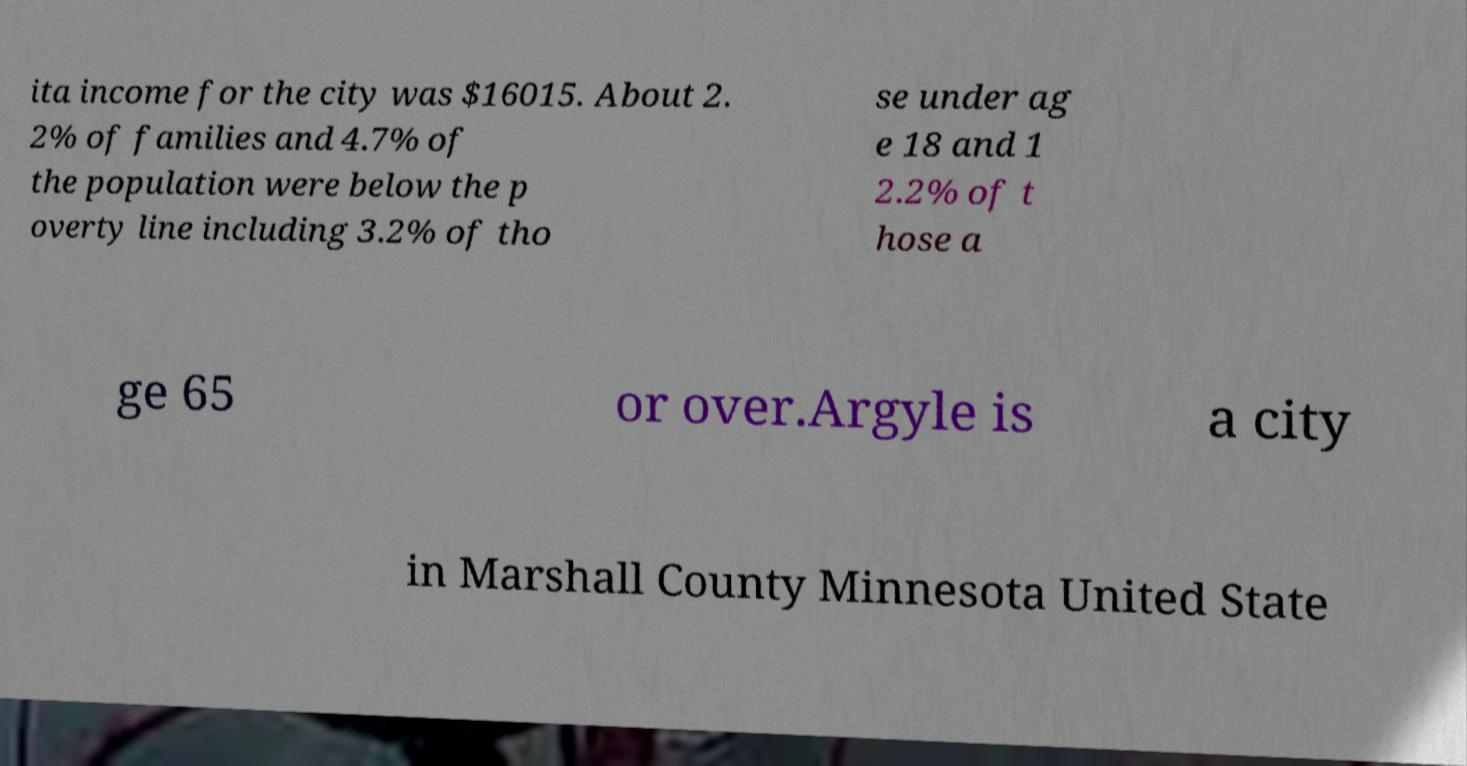There's text embedded in this image that I need extracted. Can you transcribe it verbatim? ita income for the city was $16015. About 2. 2% of families and 4.7% of the population were below the p overty line including 3.2% of tho se under ag e 18 and 1 2.2% of t hose a ge 65 or over.Argyle is a city in Marshall County Minnesota United State 